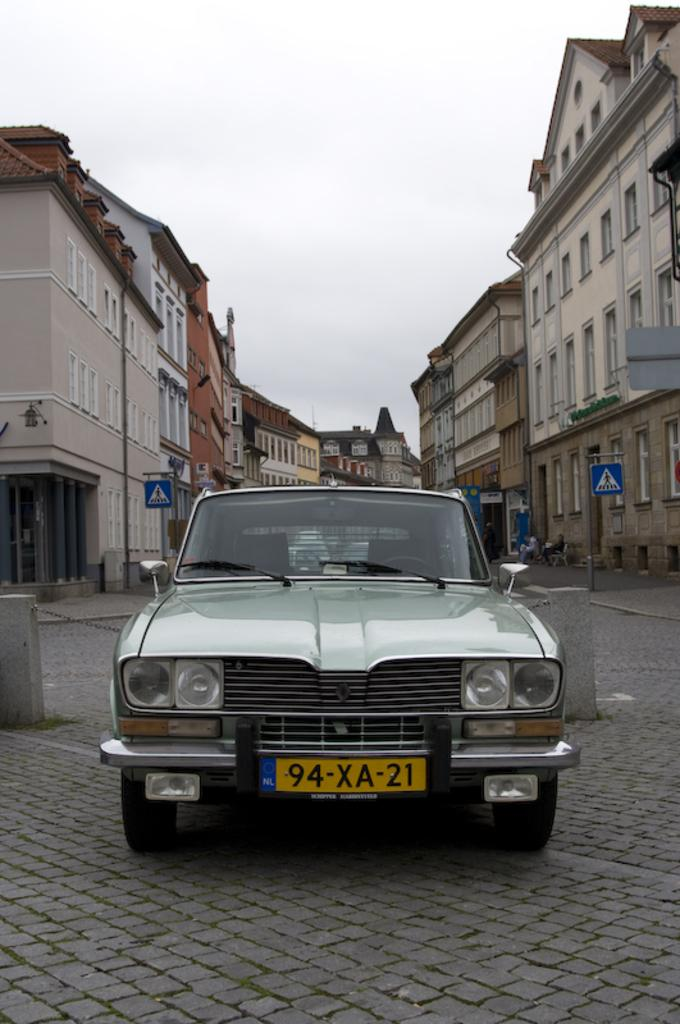What is the main subject of the image? The main subject of the image is a car. Where is the car located in the image? The car is on the road in the image. What can be seen in the background of the image? There are sign boards, buildings, and the sky visible in the background of the image. What type of quince is being used to decorate the car in the image? There is no quince present in the image, as it is a picture of a car on the road with sign boards, buildings, and the sky in the background. 